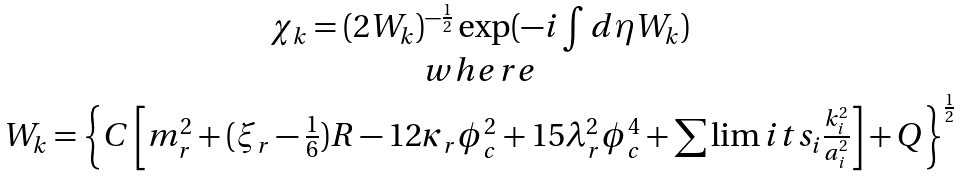<formula> <loc_0><loc_0><loc_500><loc_500>\begin{array} { c } \chi _ { k } = ( 2 W _ { k } ) ^ { - \frac { 1 } { 2 } } \exp ( - i \int d \eta W _ { k } ) \\ w h e r e \\ W _ { k } = \left \{ C \left [ m _ { r } ^ { 2 } + ( \xi _ { r } - \frac { 1 } { 6 } ) R - 1 2 \kappa _ { r } \phi _ { c } ^ { 2 } + 1 5 \lambda _ { r } ^ { 2 } \phi _ { c } ^ { 4 } + \sum \lim i t s _ { i } \frac { k _ { i } ^ { 2 } } { a _ { i } ^ { 2 } } \right ] + Q \right \} ^ { \frac { 1 } { 2 } } \end{array}</formula> 